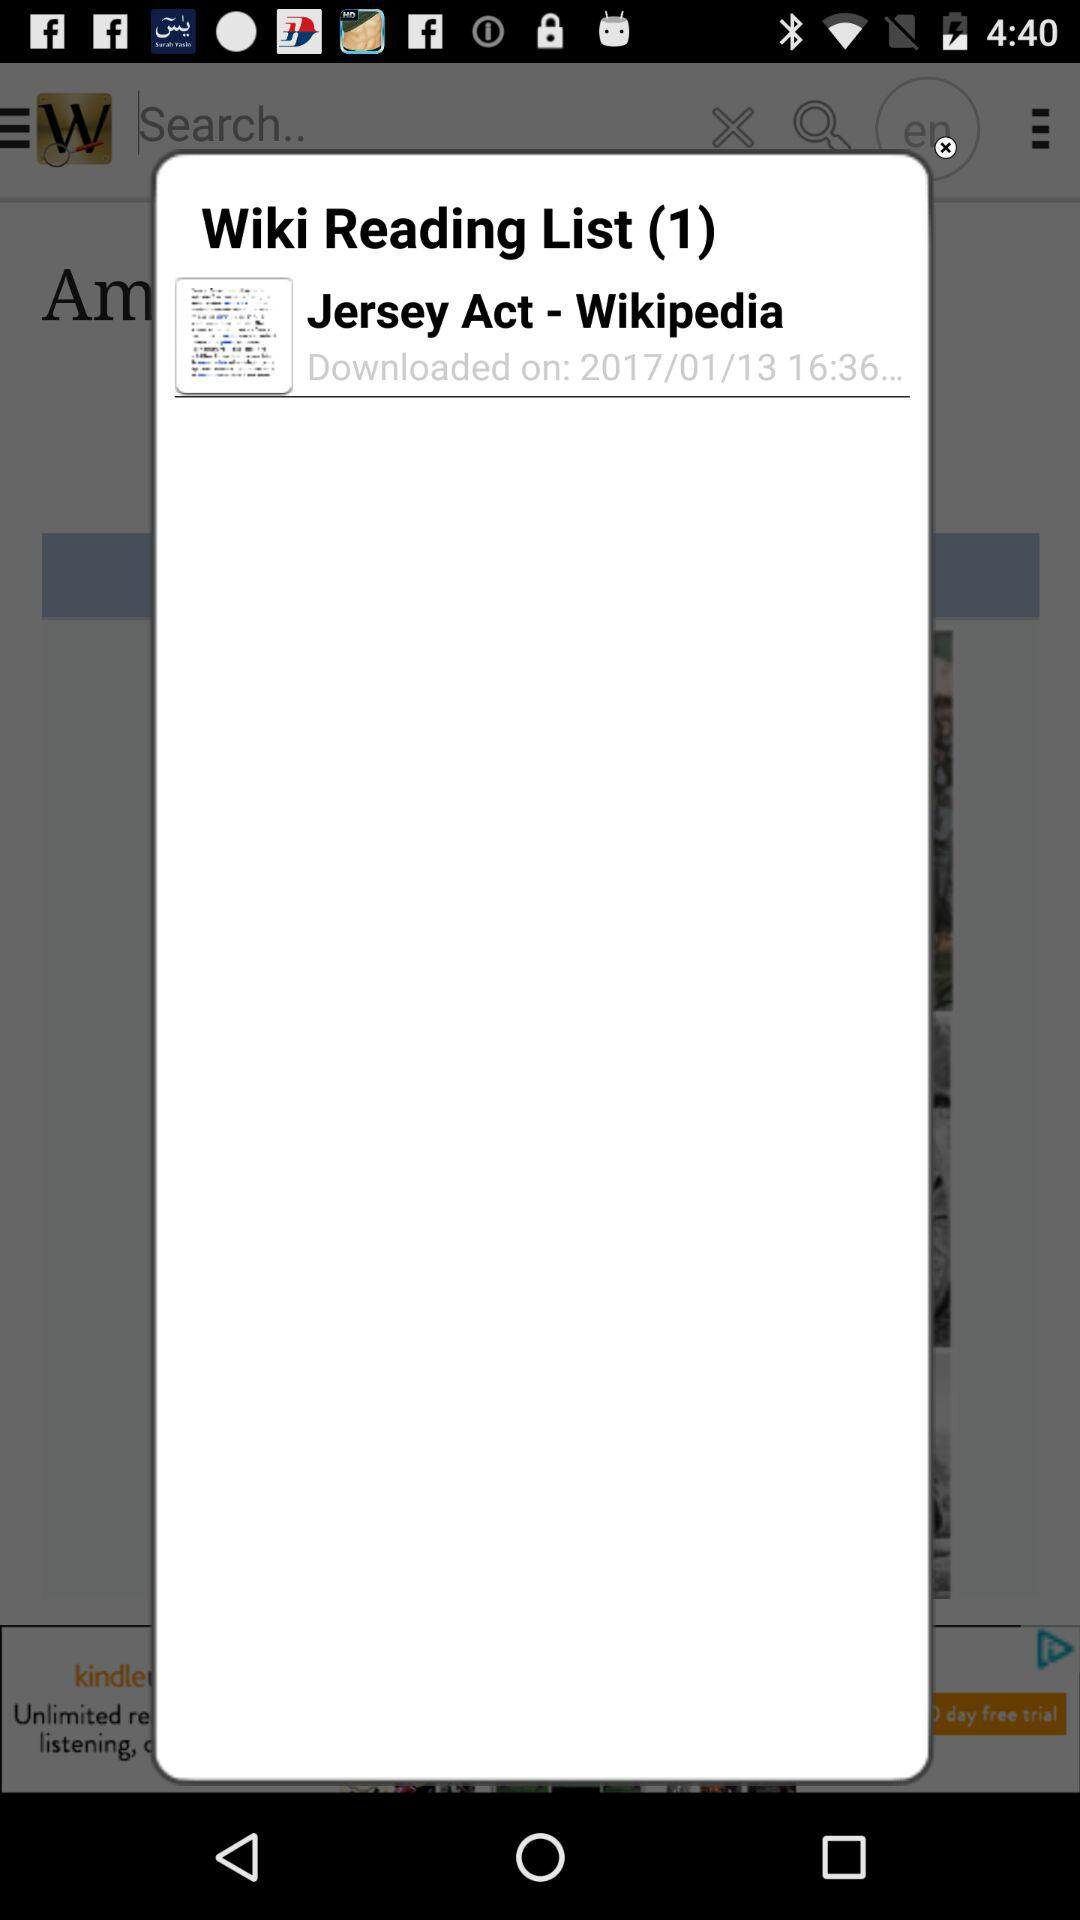At what time was the "Jersey Act" downloaded? The "Jersey Act" was downloaded at 16:36. 